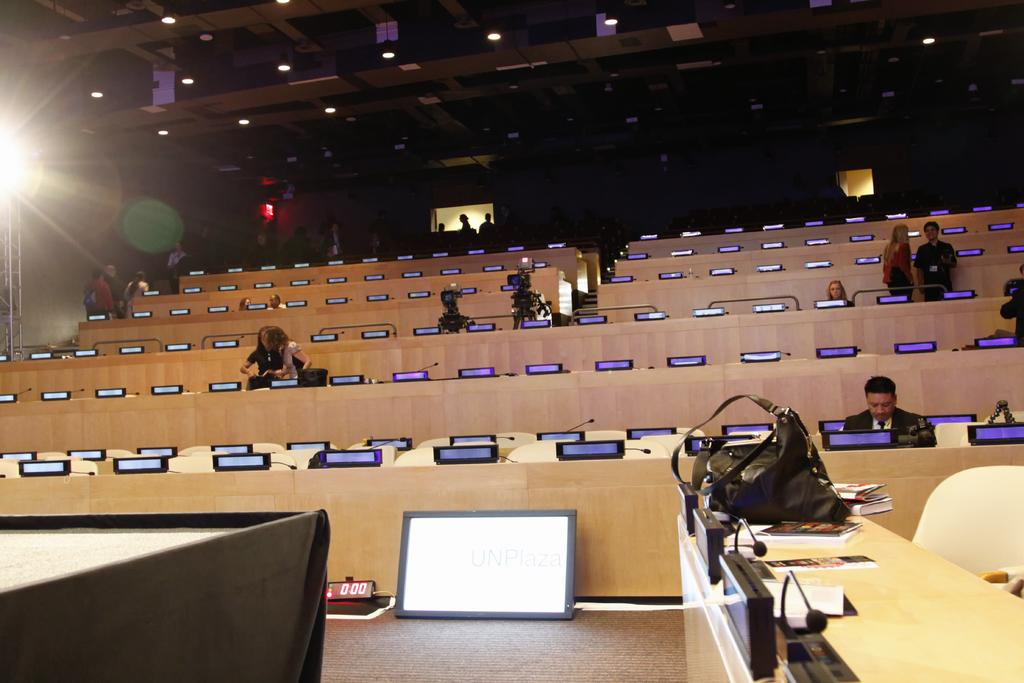What type of furniture is present in the image? There are tables in the image. What are the people in the image doing? The people in the image are standing and sitting. What items can be seen on one of the tables? There are books, microphones (mics), and a black color handbag on one of the tables. What type of leaf is present on the table in the image? There is no leaf present on the table in the image. What type of prose can be heard from the people in the image? The image does not provide any information about the people speaking or any prose being spoken. 